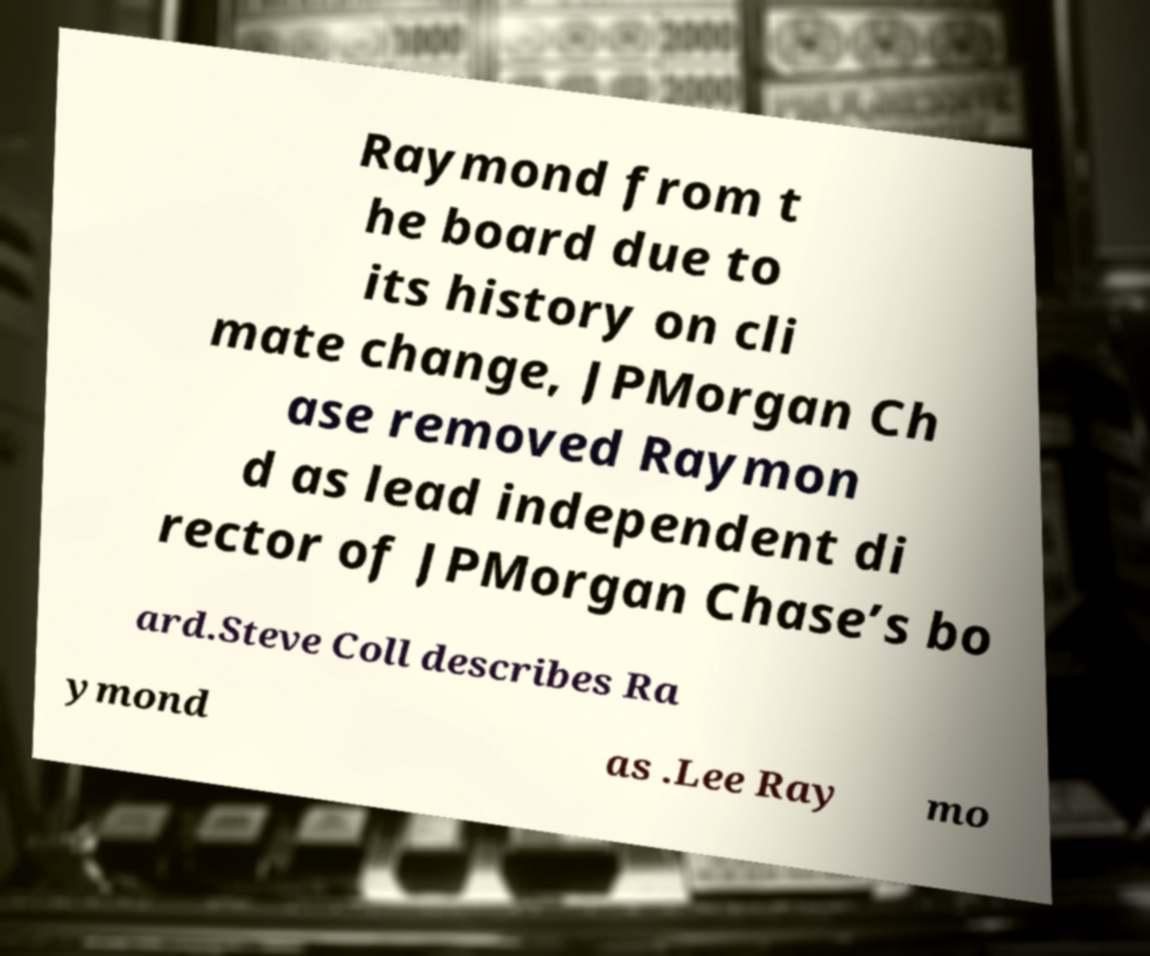Could you extract and type out the text from this image? Raymond from t he board due to its history on cli mate change, JPMorgan Ch ase removed Raymon d as lead independent di rector of JPMorgan Chase’s bo ard.Steve Coll describes Ra ymond as .Lee Ray mo 